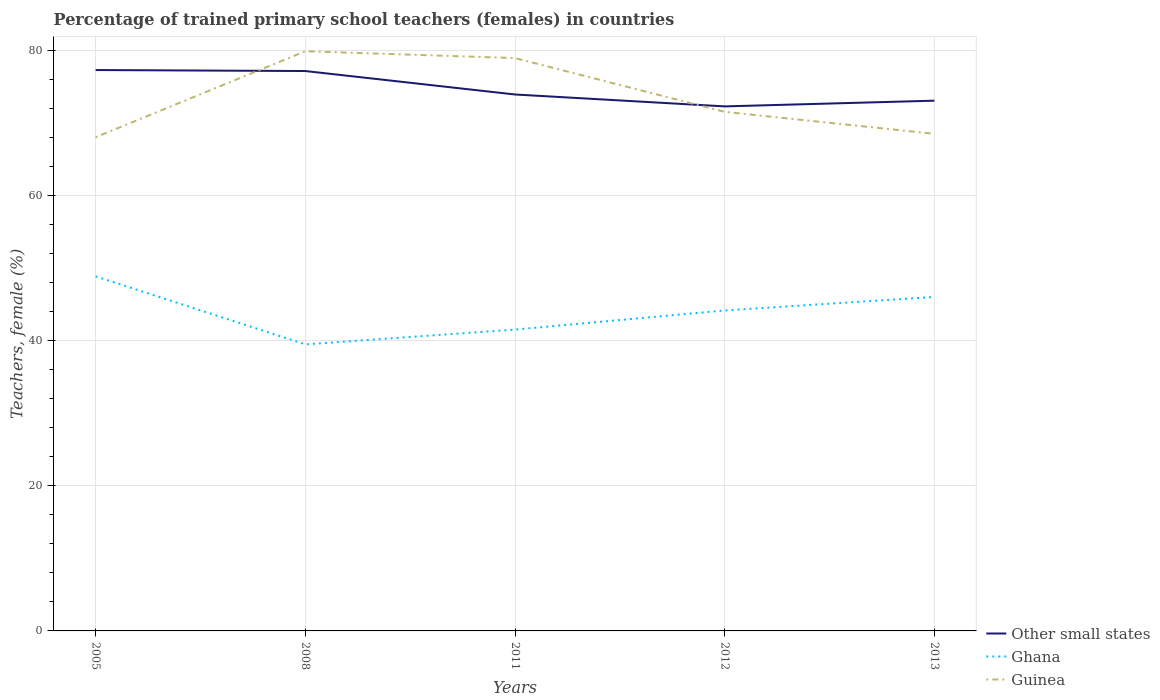Does the line corresponding to Guinea intersect with the line corresponding to Ghana?
Give a very brief answer. No. Is the number of lines equal to the number of legend labels?
Offer a terse response. Yes. Across all years, what is the maximum percentage of trained primary school teachers (females) in Ghana?
Your answer should be compact. 39.52. In which year was the percentage of trained primary school teachers (females) in Other small states maximum?
Keep it short and to the point. 2012. What is the total percentage of trained primary school teachers (females) in Ghana in the graph?
Provide a short and direct response. 4.7. What is the difference between the highest and the second highest percentage of trained primary school teachers (females) in Ghana?
Offer a terse response. 9.38. What is the difference between the highest and the lowest percentage of trained primary school teachers (females) in Other small states?
Keep it short and to the point. 2. How many years are there in the graph?
Your response must be concise. 5. Are the values on the major ticks of Y-axis written in scientific E-notation?
Your response must be concise. No. Does the graph contain grids?
Keep it short and to the point. Yes. How are the legend labels stacked?
Keep it short and to the point. Vertical. What is the title of the graph?
Your response must be concise. Percentage of trained primary school teachers (females) in countries. What is the label or title of the X-axis?
Provide a succinct answer. Years. What is the label or title of the Y-axis?
Make the answer very short. Teachers, female (%). What is the Teachers, female (%) of Other small states in 2005?
Your answer should be compact. 77.36. What is the Teachers, female (%) of Ghana in 2005?
Keep it short and to the point. 48.9. What is the Teachers, female (%) in Guinea in 2005?
Provide a short and direct response. 68.08. What is the Teachers, female (%) of Other small states in 2008?
Keep it short and to the point. 77.22. What is the Teachers, female (%) of Ghana in 2008?
Your answer should be very brief. 39.52. What is the Teachers, female (%) in Guinea in 2008?
Keep it short and to the point. 79.95. What is the Teachers, female (%) of Other small states in 2011?
Make the answer very short. 73.98. What is the Teachers, female (%) in Ghana in 2011?
Keep it short and to the point. 41.56. What is the Teachers, female (%) of Guinea in 2011?
Offer a terse response. 79.01. What is the Teachers, female (%) of Other small states in 2012?
Make the answer very short. 72.34. What is the Teachers, female (%) in Ghana in 2012?
Ensure brevity in your answer.  44.2. What is the Teachers, female (%) of Guinea in 2012?
Your answer should be compact. 71.59. What is the Teachers, female (%) in Other small states in 2013?
Keep it short and to the point. 73.13. What is the Teachers, female (%) in Ghana in 2013?
Provide a succinct answer. 46.06. What is the Teachers, female (%) of Guinea in 2013?
Offer a very short reply. 68.56. Across all years, what is the maximum Teachers, female (%) of Other small states?
Ensure brevity in your answer.  77.36. Across all years, what is the maximum Teachers, female (%) of Ghana?
Offer a very short reply. 48.9. Across all years, what is the maximum Teachers, female (%) in Guinea?
Your answer should be compact. 79.95. Across all years, what is the minimum Teachers, female (%) in Other small states?
Provide a short and direct response. 72.34. Across all years, what is the minimum Teachers, female (%) of Ghana?
Your answer should be very brief. 39.52. Across all years, what is the minimum Teachers, female (%) in Guinea?
Your response must be concise. 68.08. What is the total Teachers, female (%) in Other small states in the graph?
Your answer should be compact. 374.03. What is the total Teachers, female (%) in Ghana in the graph?
Offer a terse response. 220.25. What is the total Teachers, female (%) of Guinea in the graph?
Ensure brevity in your answer.  367.19. What is the difference between the Teachers, female (%) in Other small states in 2005 and that in 2008?
Give a very brief answer. 0.14. What is the difference between the Teachers, female (%) in Ghana in 2005 and that in 2008?
Provide a succinct answer. 9.38. What is the difference between the Teachers, female (%) of Guinea in 2005 and that in 2008?
Offer a terse response. -11.86. What is the difference between the Teachers, female (%) of Other small states in 2005 and that in 2011?
Make the answer very short. 3.37. What is the difference between the Teachers, female (%) of Ghana in 2005 and that in 2011?
Your response must be concise. 7.34. What is the difference between the Teachers, female (%) in Guinea in 2005 and that in 2011?
Provide a succinct answer. -10.92. What is the difference between the Teachers, female (%) of Other small states in 2005 and that in 2012?
Keep it short and to the point. 5.02. What is the difference between the Teachers, female (%) in Ghana in 2005 and that in 2012?
Your answer should be compact. 4.7. What is the difference between the Teachers, female (%) in Guinea in 2005 and that in 2012?
Offer a very short reply. -3.5. What is the difference between the Teachers, female (%) of Other small states in 2005 and that in 2013?
Keep it short and to the point. 4.23. What is the difference between the Teachers, female (%) in Ghana in 2005 and that in 2013?
Give a very brief answer. 2.84. What is the difference between the Teachers, female (%) of Guinea in 2005 and that in 2013?
Your response must be concise. -0.47. What is the difference between the Teachers, female (%) in Other small states in 2008 and that in 2011?
Keep it short and to the point. 3.23. What is the difference between the Teachers, female (%) of Ghana in 2008 and that in 2011?
Offer a very short reply. -2.04. What is the difference between the Teachers, female (%) in Guinea in 2008 and that in 2011?
Offer a very short reply. 0.94. What is the difference between the Teachers, female (%) in Other small states in 2008 and that in 2012?
Give a very brief answer. 4.88. What is the difference between the Teachers, female (%) in Ghana in 2008 and that in 2012?
Your answer should be very brief. -4.68. What is the difference between the Teachers, female (%) in Guinea in 2008 and that in 2012?
Your answer should be compact. 8.36. What is the difference between the Teachers, female (%) of Other small states in 2008 and that in 2013?
Make the answer very short. 4.09. What is the difference between the Teachers, female (%) of Ghana in 2008 and that in 2013?
Make the answer very short. -6.55. What is the difference between the Teachers, female (%) in Guinea in 2008 and that in 2013?
Ensure brevity in your answer.  11.39. What is the difference between the Teachers, female (%) in Other small states in 2011 and that in 2012?
Your answer should be very brief. 1.64. What is the difference between the Teachers, female (%) in Ghana in 2011 and that in 2012?
Ensure brevity in your answer.  -2.64. What is the difference between the Teachers, female (%) of Guinea in 2011 and that in 2012?
Your response must be concise. 7.42. What is the difference between the Teachers, female (%) of Other small states in 2011 and that in 2013?
Offer a terse response. 0.85. What is the difference between the Teachers, female (%) in Ghana in 2011 and that in 2013?
Your answer should be compact. -4.5. What is the difference between the Teachers, female (%) in Guinea in 2011 and that in 2013?
Your response must be concise. 10.45. What is the difference between the Teachers, female (%) in Other small states in 2012 and that in 2013?
Keep it short and to the point. -0.79. What is the difference between the Teachers, female (%) of Ghana in 2012 and that in 2013?
Keep it short and to the point. -1.87. What is the difference between the Teachers, female (%) of Guinea in 2012 and that in 2013?
Your answer should be compact. 3.03. What is the difference between the Teachers, female (%) of Other small states in 2005 and the Teachers, female (%) of Ghana in 2008?
Offer a terse response. 37.84. What is the difference between the Teachers, female (%) in Other small states in 2005 and the Teachers, female (%) in Guinea in 2008?
Ensure brevity in your answer.  -2.59. What is the difference between the Teachers, female (%) in Ghana in 2005 and the Teachers, female (%) in Guinea in 2008?
Your answer should be very brief. -31.05. What is the difference between the Teachers, female (%) of Other small states in 2005 and the Teachers, female (%) of Ghana in 2011?
Provide a succinct answer. 35.8. What is the difference between the Teachers, female (%) in Other small states in 2005 and the Teachers, female (%) in Guinea in 2011?
Provide a succinct answer. -1.65. What is the difference between the Teachers, female (%) of Ghana in 2005 and the Teachers, female (%) of Guinea in 2011?
Ensure brevity in your answer.  -30.1. What is the difference between the Teachers, female (%) of Other small states in 2005 and the Teachers, female (%) of Ghana in 2012?
Ensure brevity in your answer.  33.16. What is the difference between the Teachers, female (%) in Other small states in 2005 and the Teachers, female (%) in Guinea in 2012?
Provide a short and direct response. 5.77. What is the difference between the Teachers, female (%) in Ghana in 2005 and the Teachers, female (%) in Guinea in 2012?
Your answer should be compact. -22.69. What is the difference between the Teachers, female (%) in Other small states in 2005 and the Teachers, female (%) in Ghana in 2013?
Give a very brief answer. 31.29. What is the difference between the Teachers, female (%) in Other small states in 2005 and the Teachers, female (%) in Guinea in 2013?
Provide a short and direct response. 8.8. What is the difference between the Teachers, female (%) of Ghana in 2005 and the Teachers, female (%) of Guinea in 2013?
Your answer should be very brief. -19.66. What is the difference between the Teachers, female (%) of Other small states in 2008 and the Teachers, female (%) of Ghana in 2011?
Make the answer very short. 35.66. What is the difference between the Teachers, female (%) of Other small states in 2008 and the Teachers, female (%) of Guinea in 2011?
Provide a short and direct response. -1.79. What is the difference between the Teachers, female (%) in Ghana in 2008 and the Teachers, female (%) in Guinea in 2011?
Your answer should be compact. -39.49. What is the difference between the Teachers, female (%) in Other small states in 2008 and the Teachers, female (%) in Ghana in 2012?
Provide a short and direct response. 33.02. What is the difference between the Teachers, female (%) in Other small states in 2008 and the Teachers, female (%) in Guinea in 2012?
Give a very brief answer. 5.63. What is the difference between the Teachers, female (%) of Ghana in 2008 and the Teachers, female (%) of Guinea in 2012?
Provide a succinct answer. -32.07. What is the difference between the Teachers, female (%) in Other small states in 2008 and the Teachers, female (%) in Ghana in 2013?
Give a very brief answer. 31.15. What is the difference between the Teachers, female (%) in Other small states in 2008 and the Teachers, female (%) in Guinea in 2013?
Provide a short and direct response. 8.66. What is the difference between the Teachers, female (%) in Ghana in 2008 and the Teachers, female (%) in Guinea in 2013?
Provide a short and direct response. -29.04. What is the difference between the Teachers, female (%) of Other small states in 2011 and the Teachers, female (%) of Ghana in 2012?
Provide a short and direct response. 29.78. What is the difference between the Teachers, female (%) in Other small states in 2011 and the Teachers, female (%) in Guinea in 2012?
Your response must be concise. 2.39. What is the difference between the Teachers, female (%) of Ghana in 2011 and the Teachers, female (%) of Guinea in 2012?
Keep it short and to the point. -30.03. What is the difference between the Teachers, female (%) of Other small states in 2011 and the Teachers, female (%) of Ghana in 2013?
Your answer should be very brief. 27.92. What is the difference between the Teachers, female (%) of Other small states in 2011 and the Teachers, female (%) of Guinea in 2013?
Your response must be concise. 5.42. What is the difference between the Teachers, female (%) of Ghana in 2011 and the Teachers, female (%) of Guinea in 2013?
Provide a short and direct response. -27. What is the difference between the Teachers, female (%) in Other small states in 2012 and the Teachers, female (%) in Ghana in 2013?
Keep it short and to the point. 26.28. What is the difference between the Teachers, female (%) in Other small states in 2012 and the Teachers, female (%) in Guinea in 2013?
Provide a short and direct response. 3.78. What is the difference between the Teachers, female (%) of Ghana in 2012 and the Teachers, female (%) of Guinea in 2013?
Make the answer very short. -24.36. What is the average Teachers, female (%) of Other small states per year?
Your answer should be very brief. 74.81. What is the average Teachers, female (%) of Ghana per year?
Offer a very short reply. 44.05. What is the average Teachers, female (%) in Guinea per year?
Keep it short and to the point. 73.44. In the year 2005, what is the difference between the Teachers, female (%) in Other small states and Teachers, female (%) in Ghana?
Keep it short and to the point. 28.45. In the year 2005, what is the difference between the Teachers, female (%) in Other small states and Teachers, female (%) in Guinea?
Your answer should be very brief. 9.27. In the year 2005, what is the difference between the Teachers, female (%) in Ghana and Teachers, female (%) in Guinea?
Make the answer very short. -19.18. In the year 2008, what is the difference between the Teachers, female (%) of Other small states and Teachers, female (%) of Ghana?
Give a very brief answer. 37.7. In the year 2008, what is the difference between the Teachers, female (%) in Other small states and Teachers, female (%) in Guinea?
Make the answer very short. -2.73. In the year 2008, what is the difference between the Teachers, female (%) in Ghana and Teachers, female (%) in Guinea?
Offer a terse response. -40.43. In the year 2011, what is the difference between the Teachers, female (%) of Other small states and Teachers, female (%) of Ghana?
Provide a short and direct response. 32.42. In the year 2011, what is the difference between the Teachers, female (%) of Other small states and Teachers, female (%) of Guinea?
Provide a succinct answer. -5.02. In the year 2011, what is the difference between the Teachers, female (%) in Ghana and Teachers, female (%) in Guinea?
Offer a very short reply. -37.45. In the year 2012, what is the difference between the Teachers, female (%) in Other small states and Teachers, female (%) in Ghana?
Make the answer very short. 28.14. In the year 2012, what is the difference between the Teachers, female (%) of Other small states and Teachers, female (%) of Guinea?
Give a very brief answer. 0.75. In the year 2012, what is the difference between the Teachers, female (%) in Ghana and Teachers, female (%) in Guinea?
Make the answer very short. -27.39. In the year 2013, what is the difference between the Teachers, female (%) of Other small states and Teachers, female (%) of Ghana?
Your answer should be very brief. 27.06. In the year 2013, what is the difference between the Teachers, female (%) in Other small states and Teachers, female (%) in Guinea?
Your answer should be compact. 4.57. In the year 2013, what is the difference between the Teachers, female (%) in Ghana and Teachers, female (%) in Guinea?
Make the answer very short. -22.49. What is the ratio of the Teachers, female (%) of Other small states in 2005 to that in 2008?
Ensure brevity in your answer.  1. What is the ratio of the Teachers, female (%) of Ghana in 2005 to that in 2008?
Ensure brevity in your answer.  1.24. What is the ratio of the Teachers, female (%) in Guinea in 2005 to that in 2008?
Provide a succinct answer. 0.85. What is the ratio of the Teachers, female (%) of Other small states in 2005 to that in 2011?
Offer a terse response. 1.05. What is the ratio of the Teachers, female (%) of Ghana in 2005 to that in 2011?
Give a very brief answer. 1.18. What is the ratio of the Teachers, female (%) of Guinea in 2005 to that in 2011?
Your response must be concise. 0.86. What is the ratio of the Teachers, female (%) in Other small states in 2005 to that in 2012?
Offer a very short reply. 1.07. What is the ratio of the Teachers, female (%) of Ghana in 2005 to that in 2012?
Give a very brief answer. 1.11. What is the ratio of the Teachers, female (%) in Guinea in 2005 to that in 2012?
Your answer should be very brief. 0.95. What is the ratio of the Teachers, female (%) in Other small states in 2005 to that in 2013?
Your answer should be compact. 1.06. What is the ratio of the Teachers, female (%) in Ghana in 2005 to that in 2013?
Provide a short and direct response. 1.06. What is the ratio of the Teachers, female (%) in Other small states in 2008 to that in 2011?
Offer a very short reply. 1.04. What is the ratio of the Teachers, female (%) in Ghana in 2008 to that in 2011?
Give a very brief answer. 0.95. What is the ratio of the Teachers, female (%) of Guinea in 2008 to that in 2011?
Keep it short and to the point. 1.01. What is the ratio of the Teachers, female (%) of Other small states in 2008 to that in 2012?
Your answer should be very brief. 1.07. What is the ratio of the Teachers, female (%) of Ghana in 2008 to that in 2012?
Make the answer very short. 0.89. What is the ratio of the Teachers, female (%) of Guinea in 2008 to that in 2012?
Provide a short and direct response. 1.12. What is the ratio of the Teachers, female (%) in Other small states in 2008 to that in 2013?
Ensure brevity in your answer.  1.06. What is the ratio of the Teachers, female (%) of Ghana in 2008 to that in 2013?
Give a very brief answer. 0.86. What is the ratio of the Teachers, female (%) in Guinea in 2008 to that in 2013?
Offer a terse response. 1.17. What is the ratio of the Teachers, female (%) in Other small states in 2011 to that in 2012?
Provide a succinct answer. 1.02. What is the ratio of the Teachers, female (%) in Ghana in 2011 to that in 2012?
Your answer should be compact. 0.94. What is the ratio of the Teachers, female (%) of Guinea in 2011 to that in 2012?
Your answer should be compact. 1.1. What is the ratio of the Teachers, female (%) in Other small states in 2011 to that in 2013?
Provide a succinct answer. 1.01. What is the ratio of the Teachers, female (%) of Ghana in 2011 to that in 2013?
Offer a very short reply. 0.9. What is the ratio of the Teachers, female (%) in Guinea in 2011 to that in 2013?
Provide a short and direct response. 1.15. What is the ratio of the Teachers, female (%) in Ghana in 2012 to that in 2013?
Your answer should be very brief. 0.96. What is the ratio of the Teachers, female (%) in Guinea in 2012 to that in 2013?
Ensure brevity in your answer.  1.04. What is the difference between the highest and the second highest Teachers, female (%) in Other small states?
Provide a succinct answer. 0.14. What is the difference between the highest and the second highest Teachers, female (%) in Ghana?
Your response must be concise. 2.84. What is the difference between the highest and the second highest Teachers, female (%) in Guinea?
Keep it short and to the point. 0.94. What is the difference between the highest and the lowest Teachers, female (%) of Other small states?
Your answer should be very brief. 5.02. What is the difference between the highest and the lowest Teachers, female (%) of Ghana?
Ensure brevity in your answer.  9.38. What is the difference between the highest and the lowest Teachers, female (%) in Guinea?
Your answer should be very brief. 11.86. 